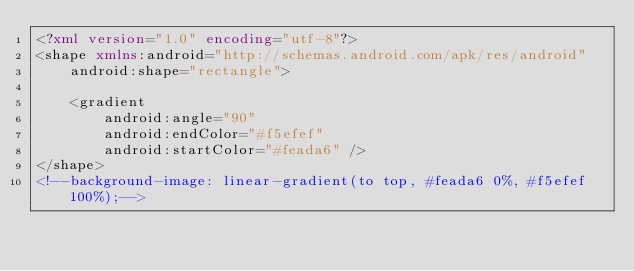<code> <loc_0><loc_0><loc_500><loc_500><_XML_><?xml version="1.0" encoding="utf-8"?>
<shape xmlns:android="http://schemas.android.com/apk/res/android"
	android:shape="rectangle">

	<gradient
		android:angle="90"
		android:endColor="#f5efef"
		android:startColor="#feada6" />
</shape>
<!--background-image: linear-gradient(to top, #feada6 0%, #f5efef 100%);--></code> 